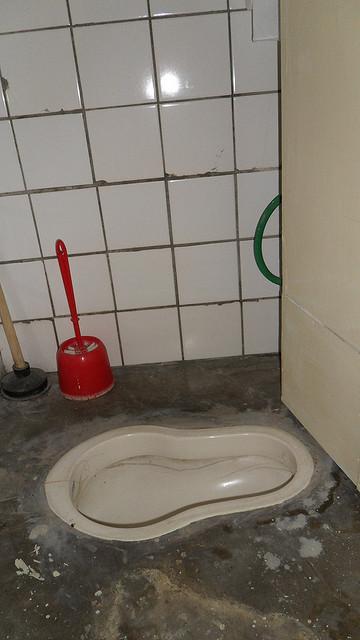How is this different from Western toilets?
Answer briefly. In ground. Is this an Arabic toilet?
Keep it brief. Yes. What is the red thing in the background?
Be succinct. Toilet brush. 